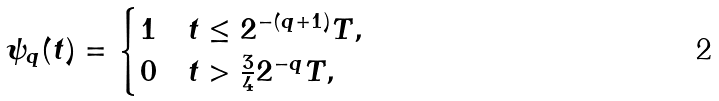Convert formula to latex. <formula><loc_0><loc_0><loc_500><loc_500>\psi _ { q } ( t ) = \begin{cases} 1 & t \leq 2 ^ { - ( q + 1 ) } T , \\ 0 & t > \frac { 3 } { 4 } 2 ^ { - q } T , \end{cases}</formula> 